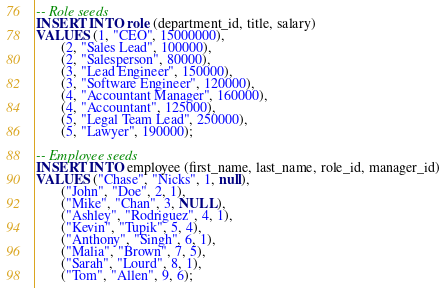Convert code to text. <code><loc_0><loc_0><loc_500><loc_500><_SQL_>-- Role seeds
INSERT INTO role (department_id, title, salary)
VALUES (1, "CEO", 15000000),
       (2, "Sales Lead", 100000),
       (2, "Salesperson", 80000),
       (3, "Lead Engineer", 150000),
       (3, "Software Engineer", 120000),
       (4, "Accountant Manager", 160000),
       (4, "Accountant", 125000),
       (5, "Legal Team Lead", 250000),
       (5, "Lawyer", 190000);

-- Employee seeds
INSERT INTO employee (first_name, last_name, role_id, manager_id)
VALUES ("Chase", "Nicks", 1, null),
       ("John", "Doe", 2, 1),
       ("Mike", "Chan", 3, NULL),
       ("Ashley", "Rodriguez", 4, 1),
       ("Kevin", "Tupik", 5, 4), 
       ("Anthony", "Singh", 6, 1),
       ("Malia", "Brown", 7, 5),
       ("Sarah", "Lourd", 8, 1),
       ("Tom", "Allen", 9, 6);</code> 